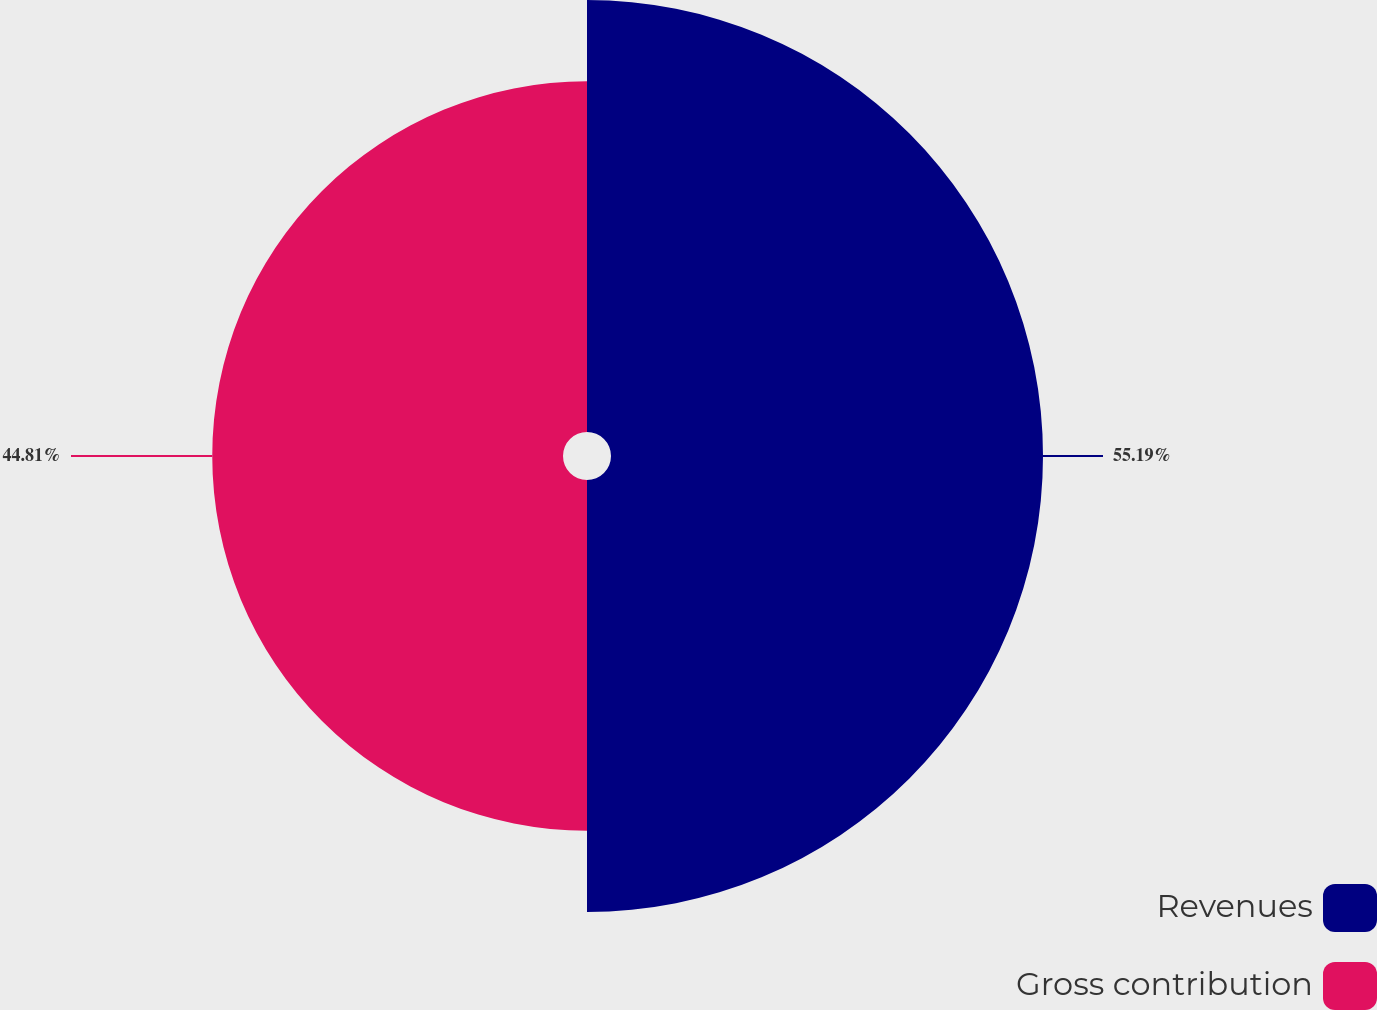<chart> <loc_0><loc_0><loc_500><loc_500><pie_chart><fcel>Revenues<fcel>Gross contribution<nl><fcel>55.19%<fcel>44.81%<nl></chart> 